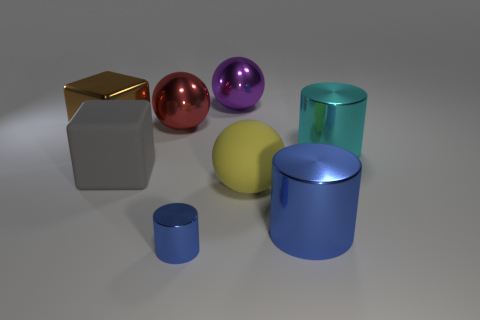What is the big thing that is to the right of the large gray matte thing and to the left of the tiny metal cylinder made of?
Provide a succinct answer. Metal. What number of other big gray things have the same shape as the gray rubber object?
Offer a very short reply. 0. There is a big cube on the left side of the gray matte block; what is it made of?
Your answer should be compact. Metal. Are there fewer big cyan metallic objects that are in front of the rubber sphere than large things?
Your response must be concise. Yes. Is the large yellow thing the same shape as the small shiny object?
Your response must be concise. No. Is there any other thing that has the same shape as the large cyan metallic thing?
Your response must be concise. Yes. Are any matte balls visible?
Ensure brevity in your answer.  Yes. There is a yellow thing; is its shape the same as the large metallic thing in front of the large cyan cylinder?
Make the answer very short. No. What is the cylinder behind the large cylinder that is on the left side of the large cyan metallic object made of?
Keep it short and to the point. Metal. The tiny object has what color?
Provide a succinct answer. Blue. 